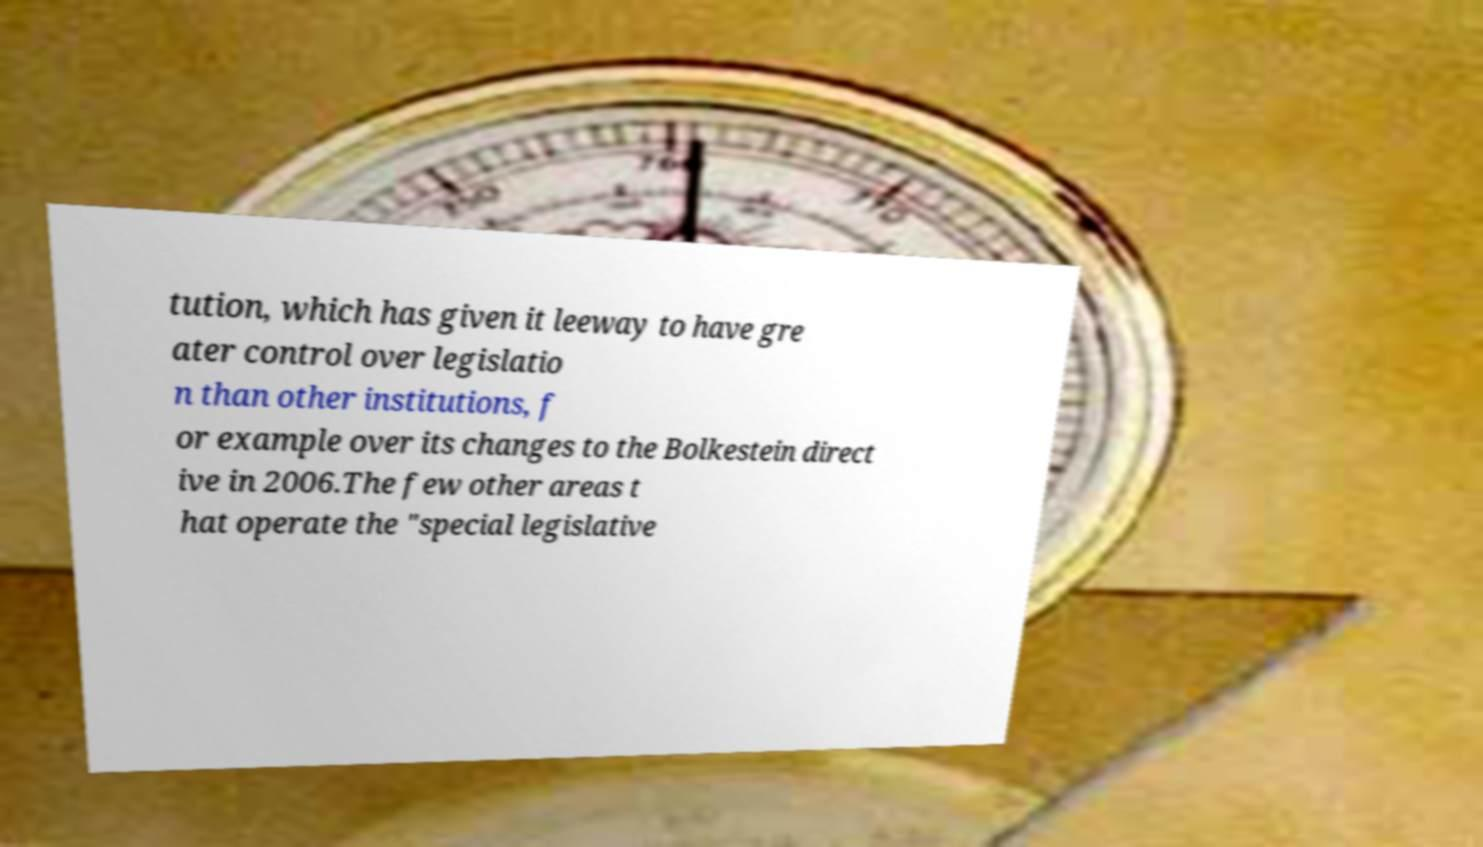There's text embedded in this image that I need extracted. Can you transcribe it verbatim? tution, which has given it leeway to have gre ater control over legislatio n than other institutions, f or example over its changes to the Bolkestein direct ive in 2006.The few other areas t hat operate the "special legislative 